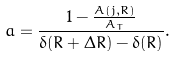<formula> <loc_0><loc_0><loc_500><loc_500>a = \frac { 1 - \frac { A ( j , R ) } { A _ { T } } } { \delta ( R + \Delta R ) - \delta ( R ) } .</formula> 